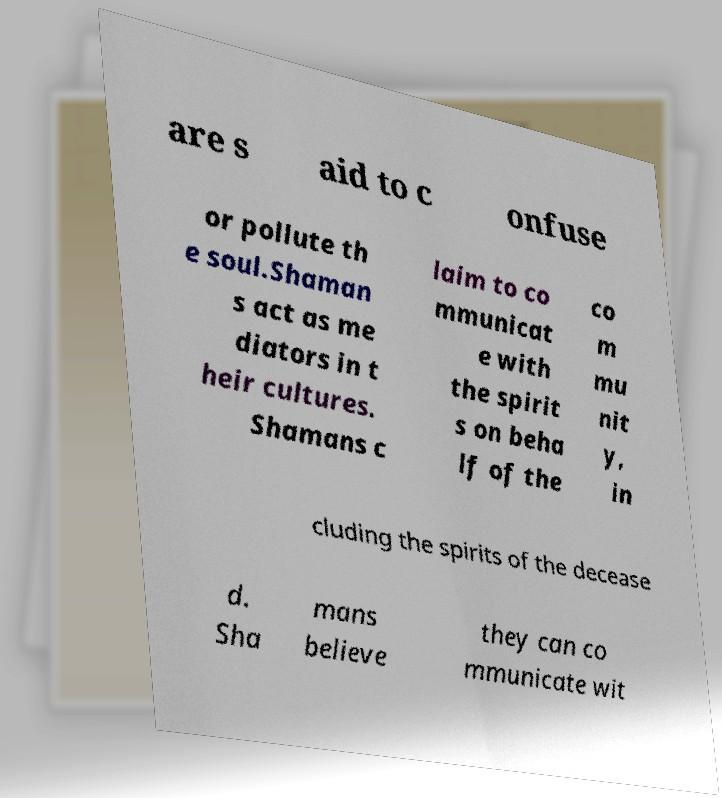Could you extract and type out the text from this image? are s aid to c onfuse or pollute th e soul.Shaman s act as me diators in t heir cultures. Shamans c laim to co mmunicat e with the spirit s on beha lf of the co m mu nit y, in cluding the spirits of the decease d. Sha mans believe they can co mmunicate wit 